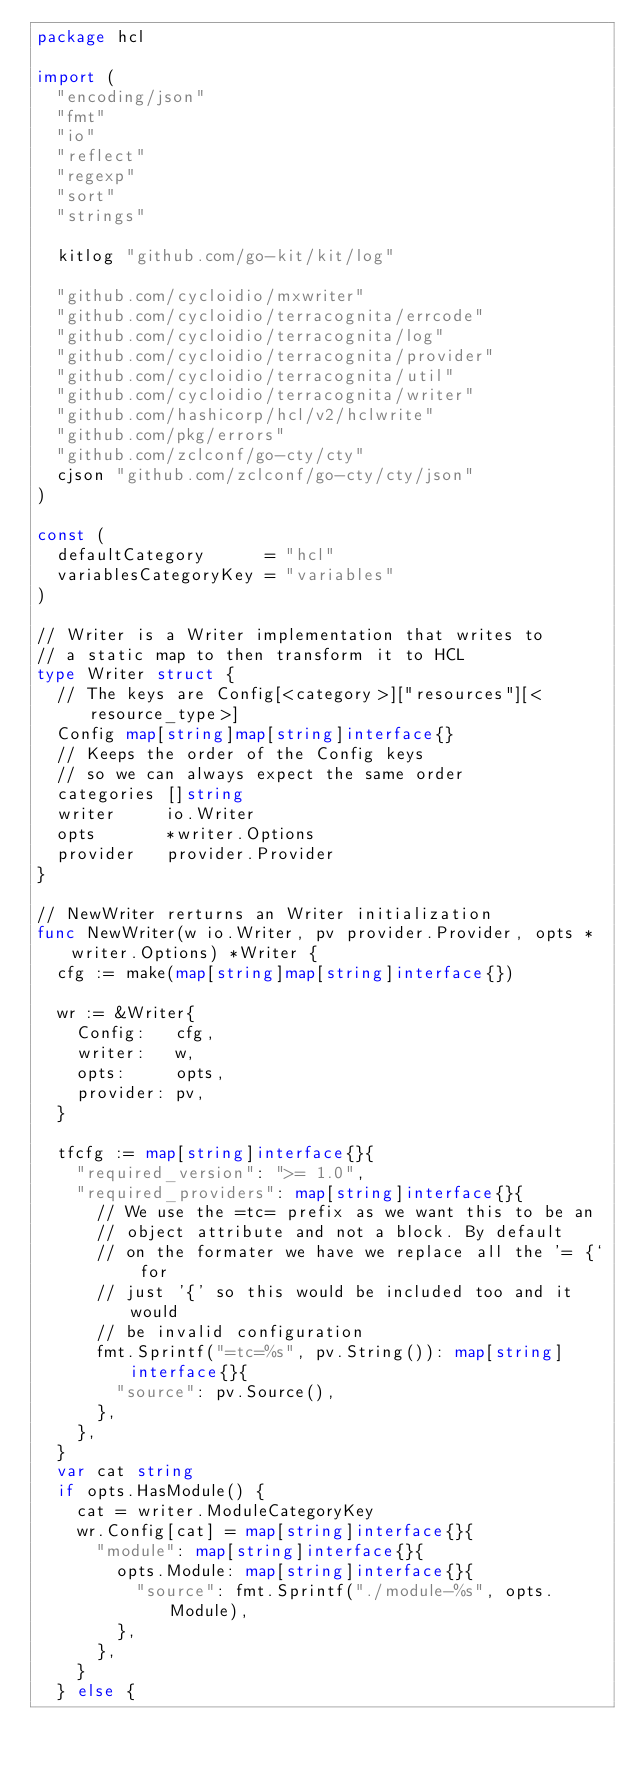Convert code to text. <code><loc_0><loc_0><loc_500><loc_500><_Go_>package hcl

import (
	"encoding/json"
	"fmt"
	"io"
	"reflect"
	"regexp"
	"sort"
	"strings"

	kitlog "github.com/go-kit/kit/log"

	"github.com/cycloidio/mxwriter"
	"github.com/cycloidio/terracognita/errcode"
	"github.com/cycloidio/terracognita/log"
	"github.com/cycloidio/terracognita/provider"
	"github.com/cycloidio/terracognita/util"
	"github.com/cycloidio/terracognita/writer"
	"github.com/hashicorp/hcl/v2/hclwrite"
	"github.com/pkg/errors"
	"github.com/zclconf/go-cty/cty"
	cjson "github.com/zclconf/go-cty/cty/json"
)

const (
	defaultCategory      = "hcl"
	variablesCategoryKey = "variables"
)

// Writer is a Writer implementation that writes to
// a static map to then transform it to HCL
type Writer struct {
	// The keys are Config[<category>]["resources"][<resource_type>]
	Config map[string]map[string]interface{}
	// Keeps the order of the Config keys
	// so we can always expect the same order
	categories []string
	writer     io.Writer
	opts       *writer.Options
	provider   provider.Provider
}

// NewWriter rerturns an Writer initialization
func NewWriter(w io.Writer, pv provider.Provider, opts *writer.Options) *Writer {
	cfg := make(map[string]map[string]interface{})

	wr := &Writer{
		Config:   cfg,
		writer:   w,
		opts:     opts,
		provider: pv,
	}

	tfcfg := map[string]interface{}{
		"required_version": ">= 1.0",
		"required_providers": map[string]interface{}{
			// We use the =tc= prefix as we want this to be an
			// object attribute and not a block. By default
			// on the formater we have we replace all the '= {` for
			// just '{' so this would be included too and it would
			// be invalid configuration
			fmt.Sprintf("=tc=%s", pv.String()): map[string]interface{}{
				"source": pv.Source(),
			},
		},
	}
	var cat string
	if opts.HasModule() {
		cat = writer.ModuleCategoryKey
		wr.Config[cat] = map[string]interface{}{
			"module": map[string]interface{}{
				opts.Module: map[string]interface{}{
					"source": fmt.Sprintf("./module-%s", opts.Module),
				},
			},
		}
	} else {</code> 